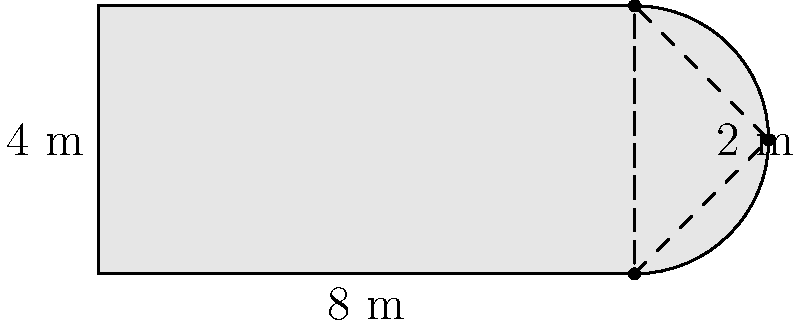As a flight attendant, you've become curious about the engineering aspects of aircraft. During a layover, you decide to estimate the area of an airplane wing. The wing can be approximated by a rectangle with a triangular tip. The rectangular part measures 8 m by 4 m, while the triangular tip has a base of 2 m and a height of 4 m. What is the total area of the wing in square meters? Let's break this down step-by-step:

1. Calculate the area of the rectangular part:
   $A_{rectangle} = length \times width = 8 \text{ m} \times 4 \text{ m} = 32 \text{ m}^2$

2. Calculate the area of the triangular tip:
   $A_{triangle} = \frac{1}{2} \times base \times height = \frac{1}{2} \times 2 \text{ m} \times 4 \text{ m} = 4 \text{ m}^2$

3. Sum up the areas to get the total wing area:
   $A_{total} = A_{rectangle} + A_{triangle} = 32 \text{ m}^2 + 4 \text{ m}^2 = 36 \text{ m}^2$

Therefore, the total area of the wing is 36 square meters.
Answer: $36 \text{ m}^2$ 